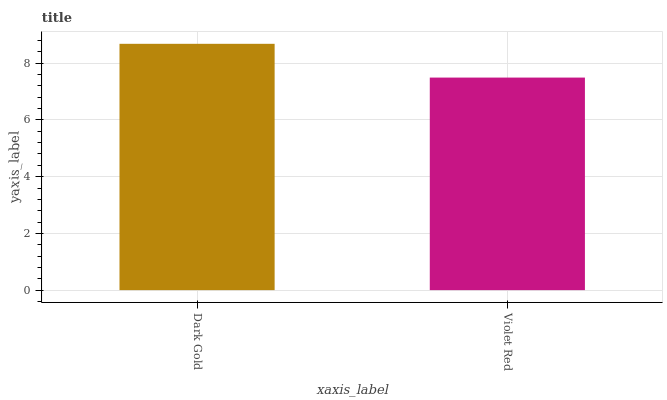Is Violet Red the minimum?
Answer yes or no. Yes. Is Dark Gold the maximum?
Answer yes or no. Yes. Is Violet Red the maximum?
Answer yes or no. No. Is Dark Gold greater than Violet Red?
Answer yes or no. Yes. Is Violet Red less than Dark Gold?
Answer yes or no. Yes. Is Violet Red greater than Dark Gold?
Answer yes or no. No. Is Dark Gold less than Violet Red?
Answer yes or no. No. Is Dark Gold the high median?
Answer yes or no. Yes. Is Violet Red the low median?
Answer yes or no. Yes. Is Violet Red the high median?
Answer yes or no. No. Is Dark Gold the low median?
Answer yes or no. No. 